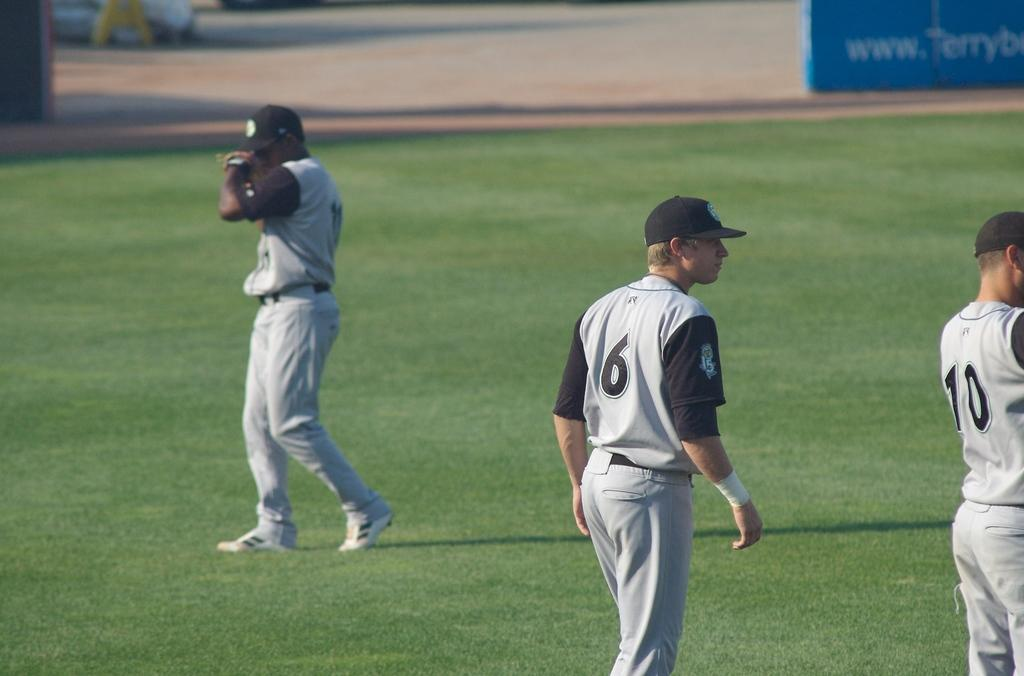<image>
Share a concise interpretation of the image provided. Players number 6 and 10 are on the grassy field. 